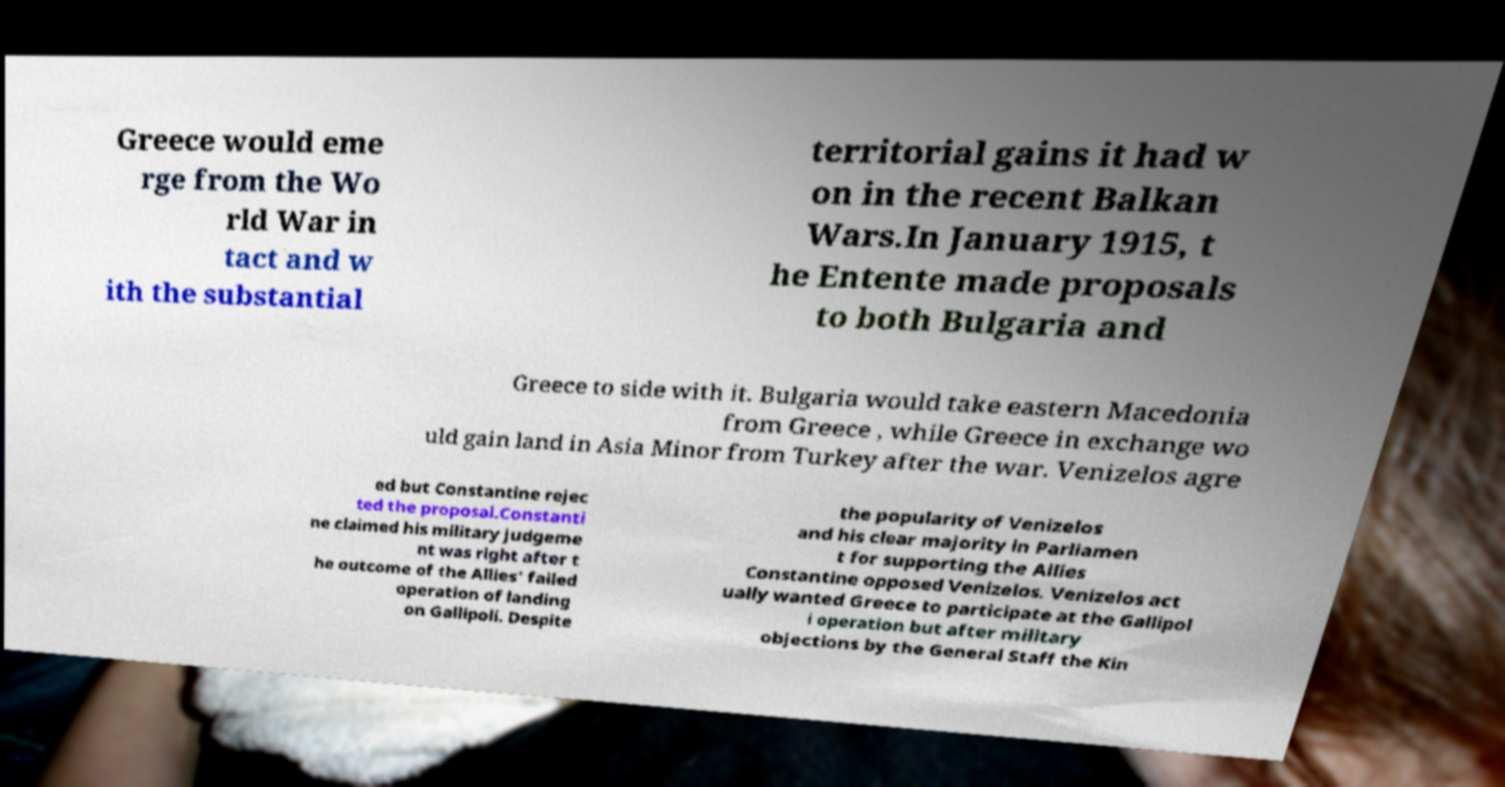Could you assist in decoding the text presented in this image and type it out clearly? Greece would eme rge from the Wo rld War in tact and w ith the substantial territorial gains it had w on in the recent Balkan Wars.In January 1915, t he Entente made proposals to both Bulgaria and Greece to side with it. Bulgaria would take eastern Macedonia from Greece , while Greece in exchange wo uld gain land in Asia Minor from Turkey after the war. Venizelos agre ed but Constantine rejec ted the proposal.Constanti ne claimed his military judgeme nt was right after t he outcome of the Allies' failed operation of landing on Gallipoli. Despite the popularity of Venizelos and his clear majority in Parliamen t for supporting the Allies Constantine opposed Venizelos. Venizelos act ually wanted Greece to participate at the Gallipol i operation but after military objections by the General Staff the Kin 